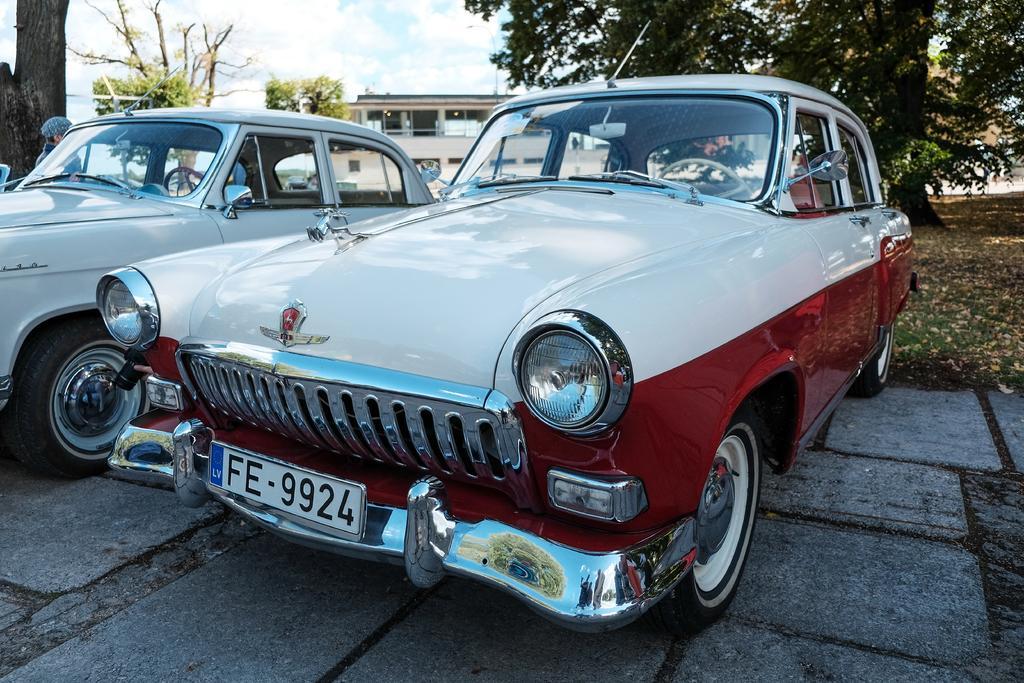How would you summarize this image in a sentence or two? In this image there is a road at the bottom. There are vehicles in the foreground. There is grass and there are trees on the right corner. There is a person and there are trees on the left corner. It looks like a building, there are trees in the background. And there is sky at the top. 